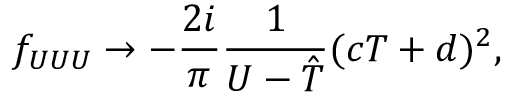Convert formula to latex. <formula><loc_0><loc_0><loc_500><loc_500>f _ { U U U } \rightarrow - \frac { 2 i } { \pi } \frac { 1 } { U - { \hat { T } } } ( c T + d ) ^ { 2 } ,</formula> 